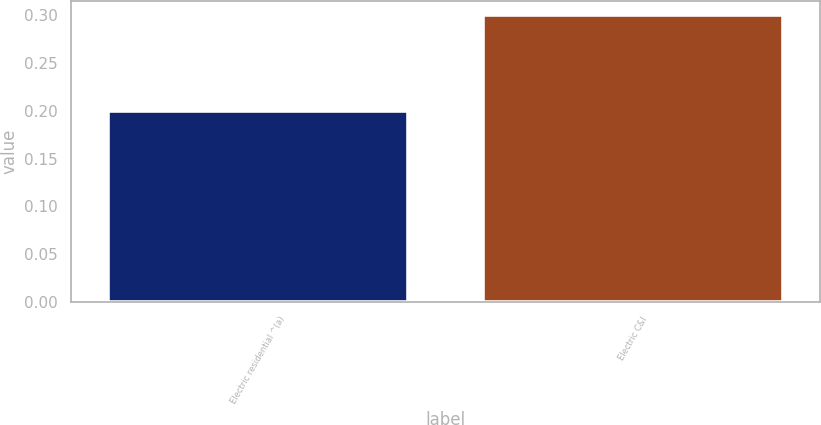<chart> <loc_0><loc_0><loc_500><loc_500><bar_chart><fcel>Electric residential ^(a)<fcel>Electric C&I<nl><fcel>0.2<fcel>0.3<nl></chart> 